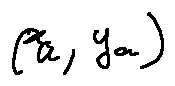Convert formula to latex. <formula><loc_0><loc_0><loc_500><loc_500>( x _ { a } , y _ { a } )</formula> 